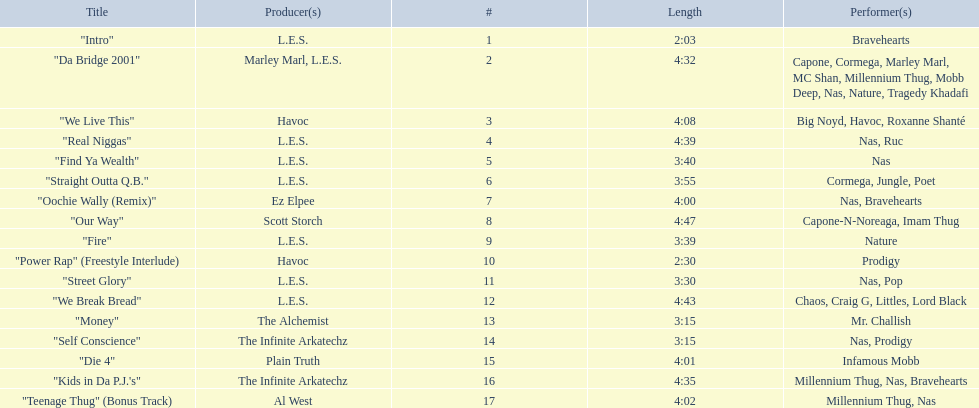How long is each song? 2:03, 4:32, 4:08, 4:39, 3:40, 3:55, 4:00, 4:47, 3:39, 2:30, 3:30, 4:43, 3:15, 3:15, 4:01, 4:35, 4:02. What length is the longest? 4:47. 